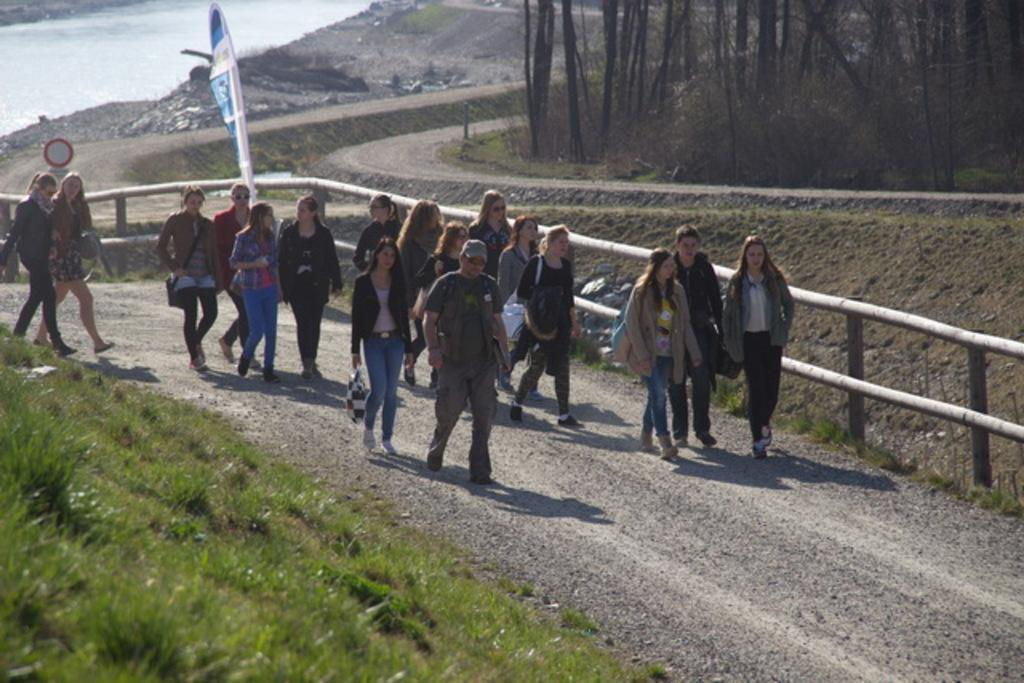What are the people in the image doing? The people in the image are standing on the road. What is the ground surface like in the image? The ground is covered with grass. What can be seen in the background of the image? There are trees and water visible in the background. What type of leather can be seen on the rabbits in the image? There are no rabbits present in the image, and therefore no leather can be seen on them. 